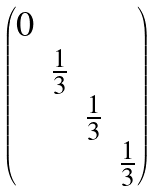Convert formula to latex. <formula><loc_0><loc_0><loc_500><loc_500>\begin{pmatrix} 0 & & & \\ & \frac { 1 } { 3 } & & \\ & & \frac { 1 } { 3 } & \\ & & & \frac { 1 } { 3 } \end{pmatrix}</formula> 